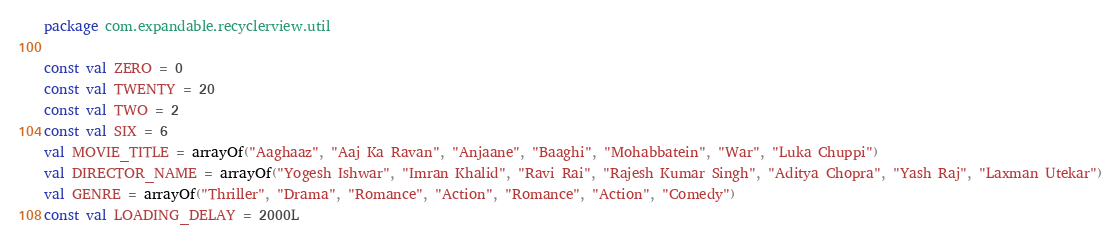<code> <loc_0><loc_0><loc_500><loc_500><_Kotlin_>package com.expandable.recyclerview.util

const val ZERO = 0
const val TWENTY = 20
const val TWO = 2
const val SIX = 6
val MOVIE_TITLE = arrayOf("Aaghaaz", "Aaj Ka Ravan", "Anjaane", "Baaghi", "Mohabbatein", "War", "Luka Chuppi")
val DIRECTOR_NAME = arrayOf("Yogesh Ishwar", "Imran Khalid", "Ravi Rai", "Rajesh Kumar Singh", "Aditya Chopra", "Yash Raj", "Laxman Utekar")
val GENRE = arrayOf("Thriller", "Drama", "Romance", "Action", "Romance", "Action", "Comedy")
const val LOADING_DELAY = 2000L</code> 